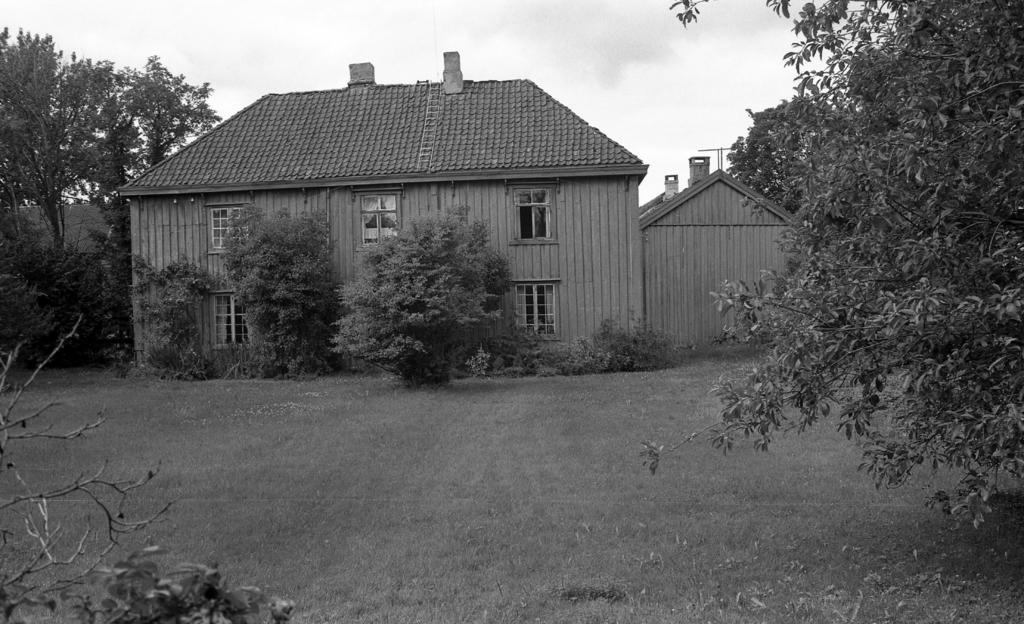What type of structure is present in the image? There is a house in the picture. What other natural elements can be seen in the image? There are plants and trees in the picture. What is visible in the background of the image? The sky is visible in the background of the picture. What type of quiver is hanging on the wall in the picture? There is no quiver present in the image; it features a house, plants, trees, and the sky. What time of day is depicted in the image? The time of day cannot be determined from the image, as there are no specific indicators of time. 